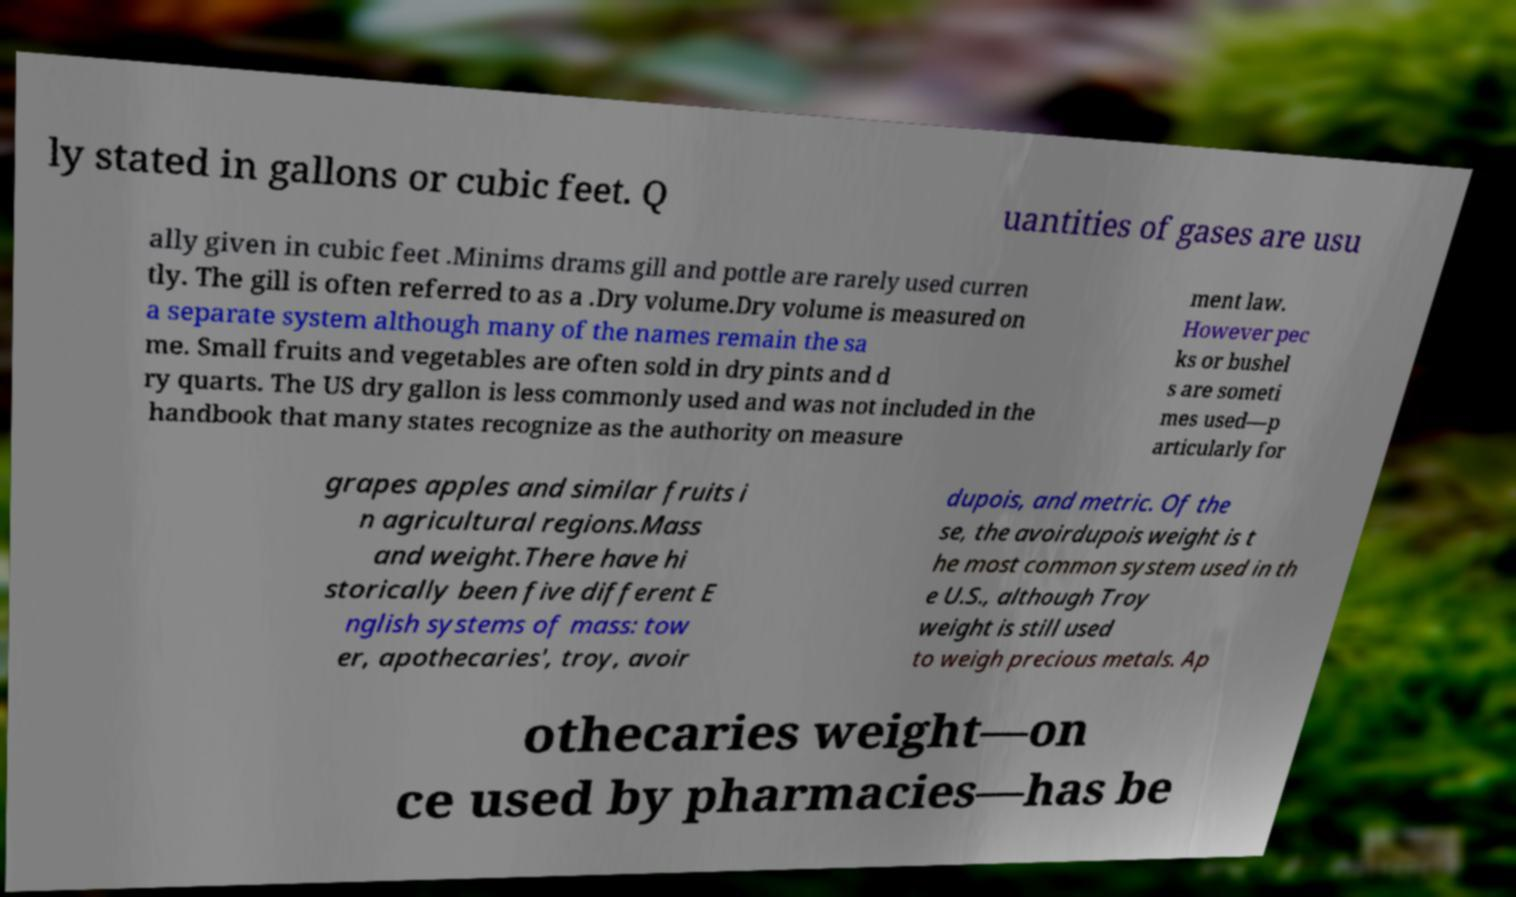There's text embedded in this image that I need extracted. Can you transcribe it verbatim? ly stated in gallons or cubic feet. Q uantities of gases are usu ally given in cubic feet .Minims drams gill and pottle are rarely used curren tly. The gill is often referred to as a .Dry volume.Dry volume is measured on a separate system although many of the names remain the sa me. Small fruits and vegetables are often sold in dry pints and d ry quarts. The US dry gallon is less commonly used and was not included in the handbook that many states recognize as the authority on measure ment law. However pec ks or bushel s are someti mes used—p articularly for grapes apples and similar fruits i n agricultural regions.Mass and weight.There have hi storically been five different E nglish systems of mass: tow er, apothecaries', troy, avoir dupois, and metric. Of the se, the avoirdupois weight is t he most common system used in th e U.S., although Troy weight is still used to weigh precious metals. Ap othecaries weight—on ce used by pharmacies—has be 